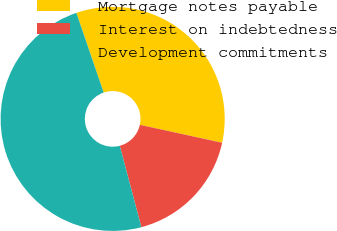Convert chart. <chart><loc_0><loc_0><loc_500><loc_500><pie_chart><fcel>Mortgage notes payable<fcel>Interest on indebtedness<fcel>Development commitments<nl><fcel>33.66%<fcel>17.46%<fcel>48.87%<nl></chart> 